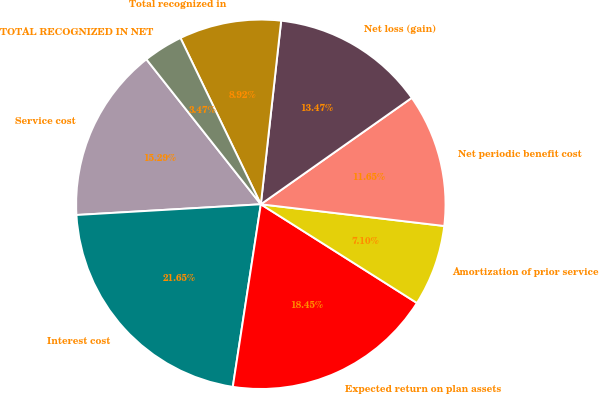Convert chart. <chart><loc_0><loc_0><loc_500><loc_500><pie_chart><fcel>Service cost<fcel>Interest cost<fcel>Expected return on plan assets<fcel>Amortization of prior service<fcel>Net periodic benefit cost<fcel>Net loss (gain)<fcel>Total recognized in<fcel>TOTAL RECOGNIZED IN NET<nl><fcel>15.29%<fcel>21.65%<fcel>18.45%<fcel>7.1%<fcel>11.65%<fcel>13.47%<fcel>8.92%<fcel>3.47%<nl></chart> 